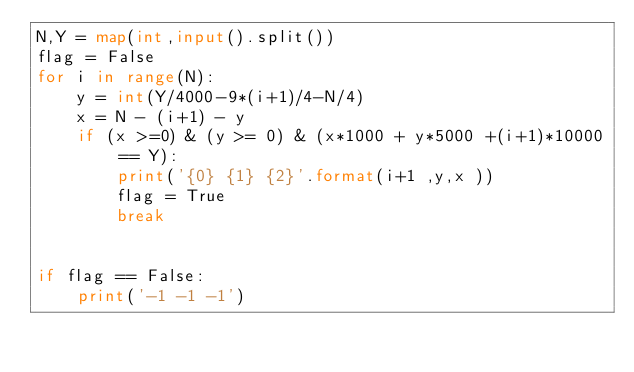Convert code to text. <code><loc_0><loc_0><loc_500><loc_500><_Python_>N,Y = map(int,input().split())
flag = False
for i in range(N):
    y = int(Y/4000-9*(i+1)/4-N/4)
    x = N - (i+1) - y
    if (x >=0) & (y >= 0) & (x*1000 + y*5000 +(i+1)*10000 == Y):
        print('{0} {1} {2}'.format(i+1 ,y,x ))
        flag = True
        break


if flag == False:
    print('-1 -1 -1')</code> 